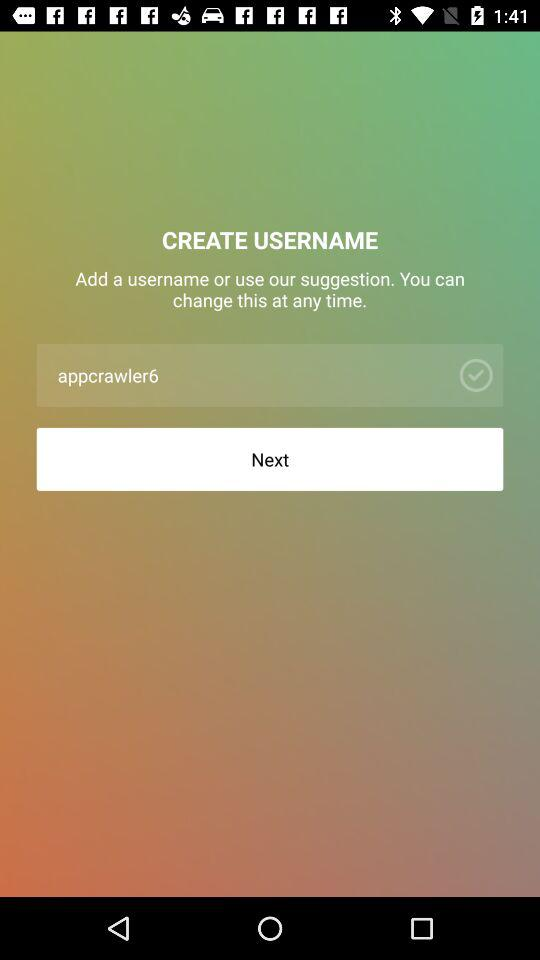What is the username? The username is "appcrawler6". 